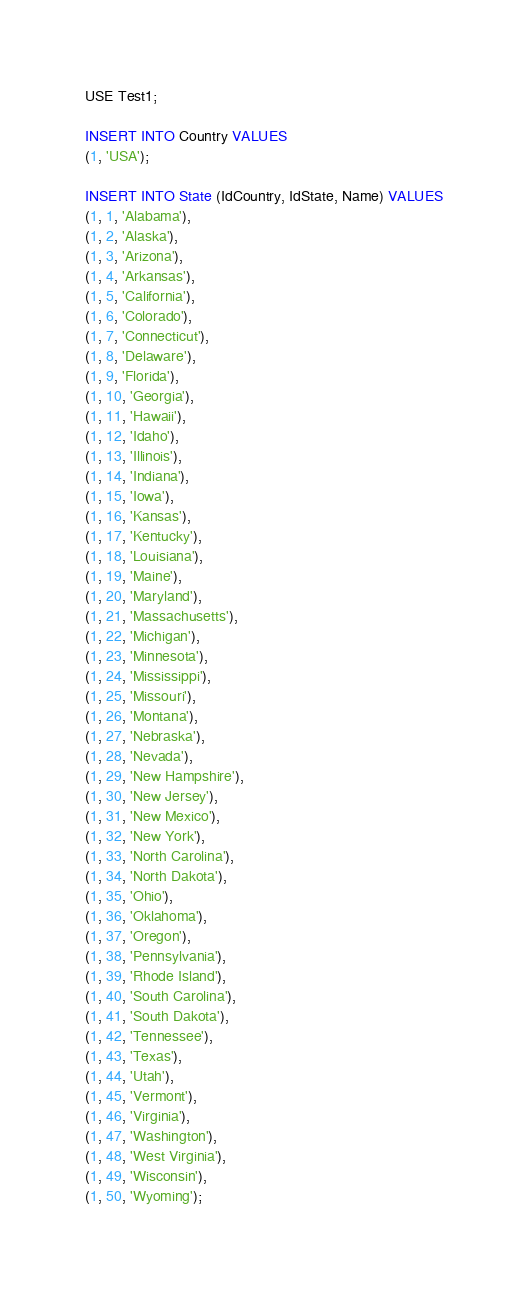Convert code to text. <code><loc_0><loc_0><loc_500><loc_500><_SQL_>USE Test1;

INSERT INTO Country VALUES
(1, 'USA');

INSERT INTO State (IdCountry, IdState, Name) VALUES
(1, 1, 'Alabama'),
(1, 2, 'Alaska'),
(1, 3, 'Arizona'),
(1, 4, 'Arkansas'),
(1, 5, 'California'),
(1, 6, 'Colorado'),
(1, 7, 'Connecticut'),
(1, 8, 'Delaware'),
(1, 9, 'Florida'),
(1, 10, 'Georgia'),
(1, 11, 'Hawaii'),
(1, 12, 'Idaho'),
(1, 13, 'Illinois'),
(1, 14, 'Indiana'),
(1, 15, 'Iowa'),
(1, 16, 'Kansas'),
(1, 17, 'Kentucky'),
(1, 18, 'Louisiana'),
(1, 19, 'Maine'),
(1, 20, 'Maryland'),
(1, 21, 'Massachusetts'),
(1, 22, 'Michigan'),
(1, 23, 'Minnesota'),
(1, 24, 'Mississippi'),
(1, 25, 'Missouri'),
(1, 26, 'Montana'),
(1, 27, 'Nebraska'),
(1, 28, 'Nevada'),
(1, 29, 'New Hampshire'),
(1, 30, 'New Jersey'),
(1, 31, 'New Mexico'),
(1, 32, 'New York'),
(1, 33, 'North Carolina'),
(1, 34, 'North Dakota'),
(1, 35, 'Ohio'),
(1, 36, 'Oklahoma'),
(1, 37, 'Oregon'),
(1, 38, 'Pennsylvania'),
(1, 39, 'Rhode Island'),
(1, 40, 'South Carolina'),
(1, 41, 'South Dakota'),
(1, 42, 'Tennessee'),
(1, 43, 'Texas'),
(1, 44, 'Utah'),
(1, 45, 'Vermont'),
(1, 46, 'Virginia'),
(1, 47, 'Washington'),
(1, 48, 'West Virginia'),
(1, 49, 'Wisconsin'),
(1, 50, 'Wyoming');</code> 